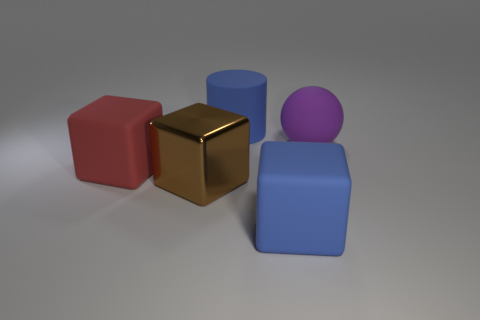What is the material of the thing that is the same color as the rubber cylinder?
Your answer should be very brief. Rubber. What number of other objects are the same color as the large cylinder?
Your answer should be very brief. 1. There is a large cylinder; does it have the same color as the large rubber block that is right of the big matte cylinder?
Make the answer very short. Yes. Is the number of red matte blocks less than the number of big rubber blocks?
Offer a terse response. Yes. What size is the rubber object that is to the left of the big blue block and in front of the sphere?
Your answer should be very brief. Large. There is a cube to the right of the matte cylinder; is its color the same as the large matte cylinder?
Give a very brief answer. Yes. Are there fewer large cubes on the left side of the large blue cylinder than small blue shiny objects?
Provide a short and direct response. No. What shape is the red object that is made of the same material as the purple ball?
Your response must be concise. Cube. Do the red cube and the big brown object have the same material?
Your answer should be compact. No. Are there fewer big red blocks that are behind the purple matte thing than blue matte things that are behind the large brown thing?
Give a very brief answer. Yes. 